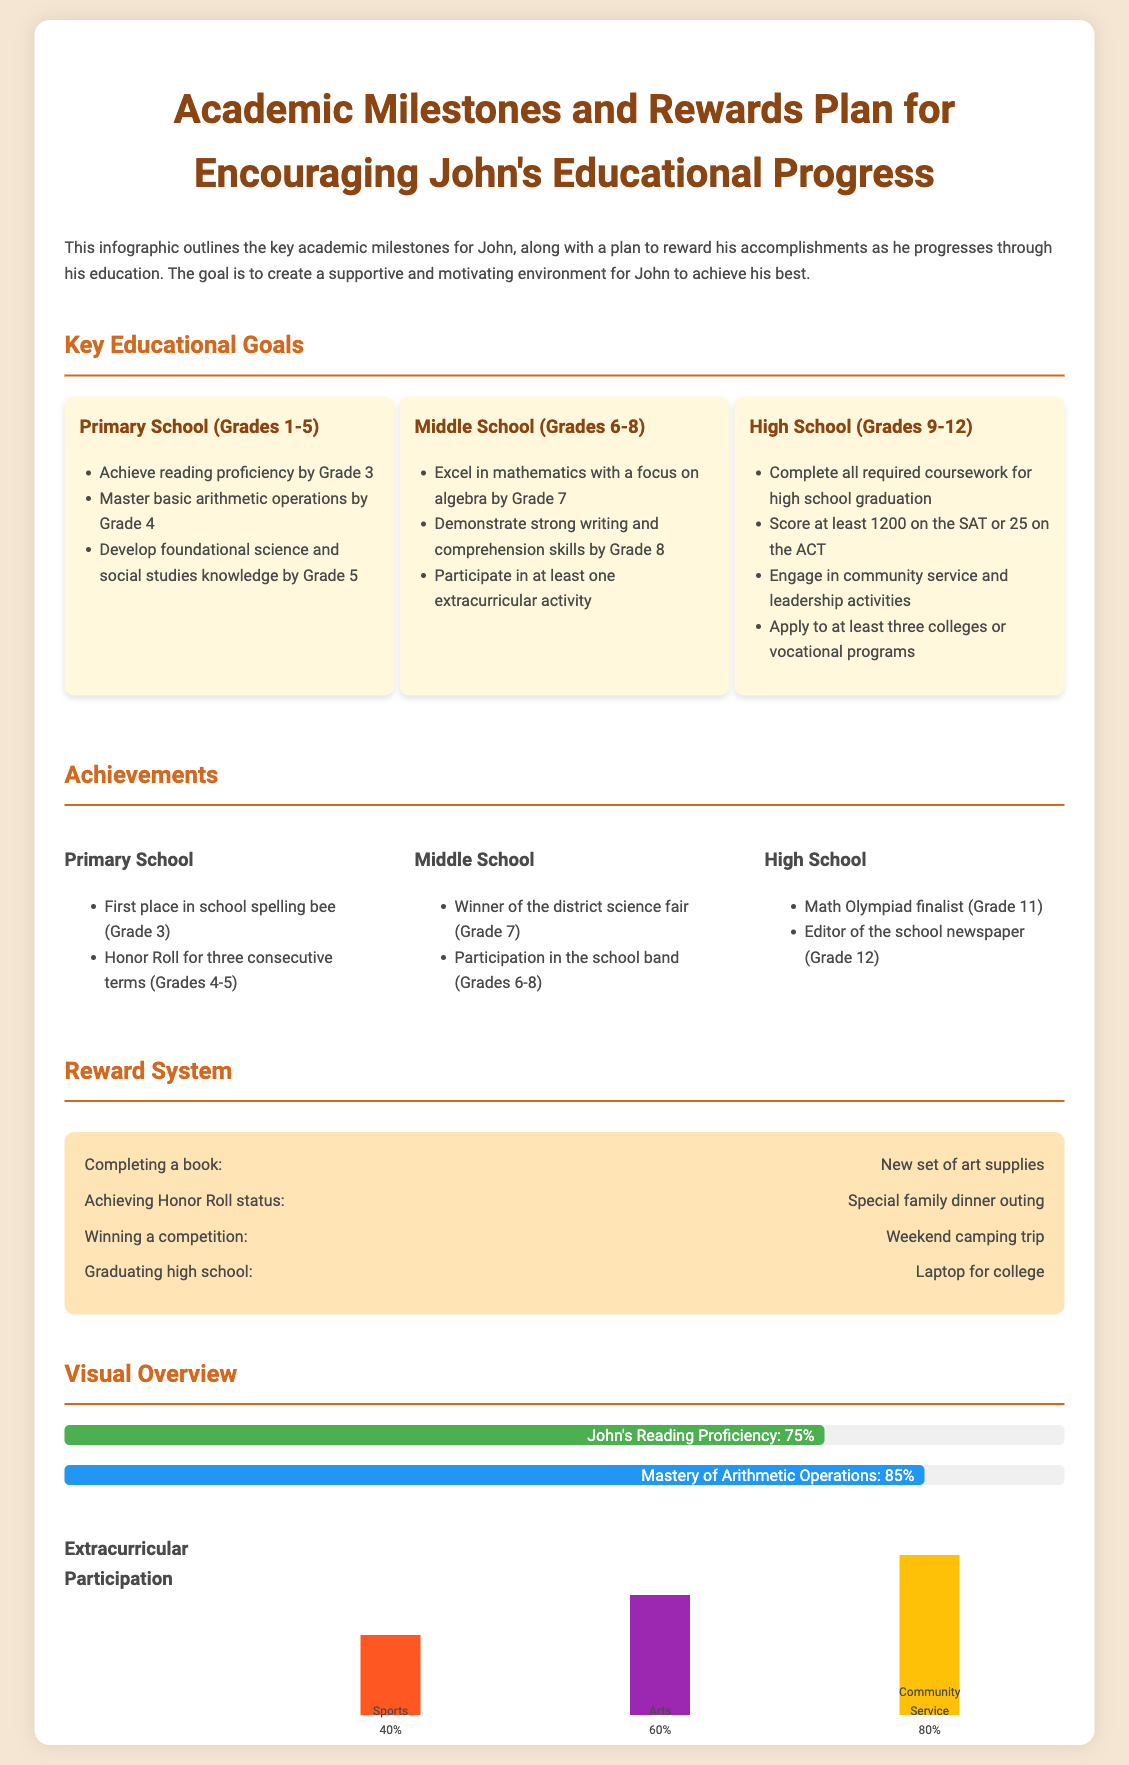What are the primary school reading proficiency goals? The document states that John should achieve reading proficiency by Grade 3 within the Primary School milestones.
Answer: Grade 3 What is the reward for achieving Honor Roll status? The infographic outlines that achieving Honor Roll status will lead to a special family dinner outing.
Answer: Special family dinner outing Which extracurricular activity has the highest participation percentage? The bar chart indicates that Community Service has the highest participation percentage of 80%.
Answer: Community Service What grade did John win first place in the spelling bee? From the achievements section, it is mentioned that John won first place in the school spelling bee in Grade 3.
Answer: Grade 3 How much progress has John made in Mastery of Arithmetic Operations? The document states that John has mastered 85% of arithmetic operations as indicated in the progress bar.
Answer: 85% What is one of the key educational goals for Middle School? The milestones outline that excelling in mathematics with a focus on algebra by Grade 7 is a key educational goal for Middle School.
Answer: Excel in mathematics with a focus on algebra by Grade 7 How many colleges or vocational programs should John apply to? According to the High School milestones, John should apply to at least three colleges or vocational programs.
Answer: At least three What was one of John's achievements in Middle School? The achievements section notes that John is the winner of the district science fair (Grade 7) as a Middle School achievement.
Answer: Winner of the district science fair Which grade level includes participating in at least one extracurricular activity? The requirements for Middle School include participating in at least one extracurricular activity.
Answer: Middle School 